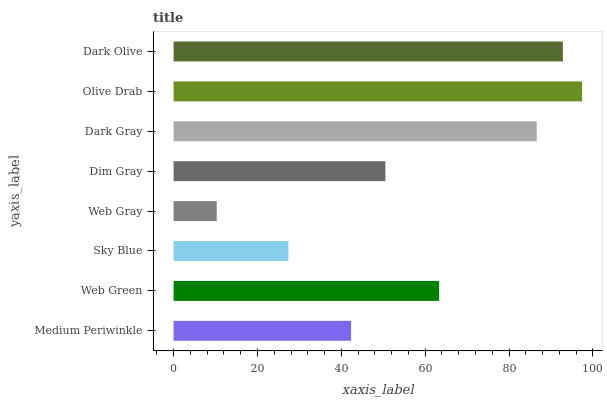Is Web Gray the minimum?
Answer yes or no. Yes. Is Olive Drab the maximum?
Answer yes or no. Yes. Is Web Green the minimum?
Answer yes or no. No. Is Web Green the maximum?
Answer yes or no. No. Is Web Green greater than Medium Periwinkle?
Answer yes or no. Yes. Is Medium Periwinkle less than Web Green?
Answer yes or no. Yes. Is Medium Periwinkle greater than Web Green?
Answer yes or no. No. Is Web Green less than Medium Periwinkle?
Answer yes or no. No. Is Web Green the high median?
Answer yes or no. Yes. Is Dim Gray the low median?
Answer yes or no. Yes. Is Medium Periwinkle the high median?
Answer yes or no. No. Is Web Green the low median?
Answer yes or no. No. 